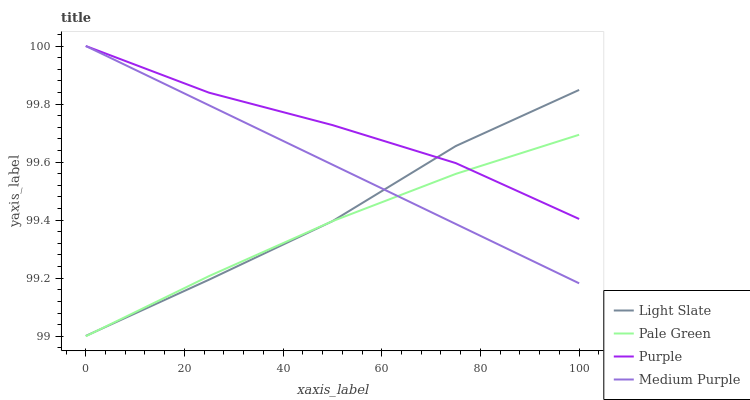Does Medium Purple have the minimum area under the curve?
Answer yes or no. No. Does Medium Purple have the maximum area under the curve?
Answer yes or no. No. Is Purple the smoothest?
Answer yes or no. No. Is Purple the roughest?
Answer yes or no. No. Does Medium Purple have the lowest value?
Answer yes or no. No. Does Pale Green have the highest value?
Answer yes or no. No. 